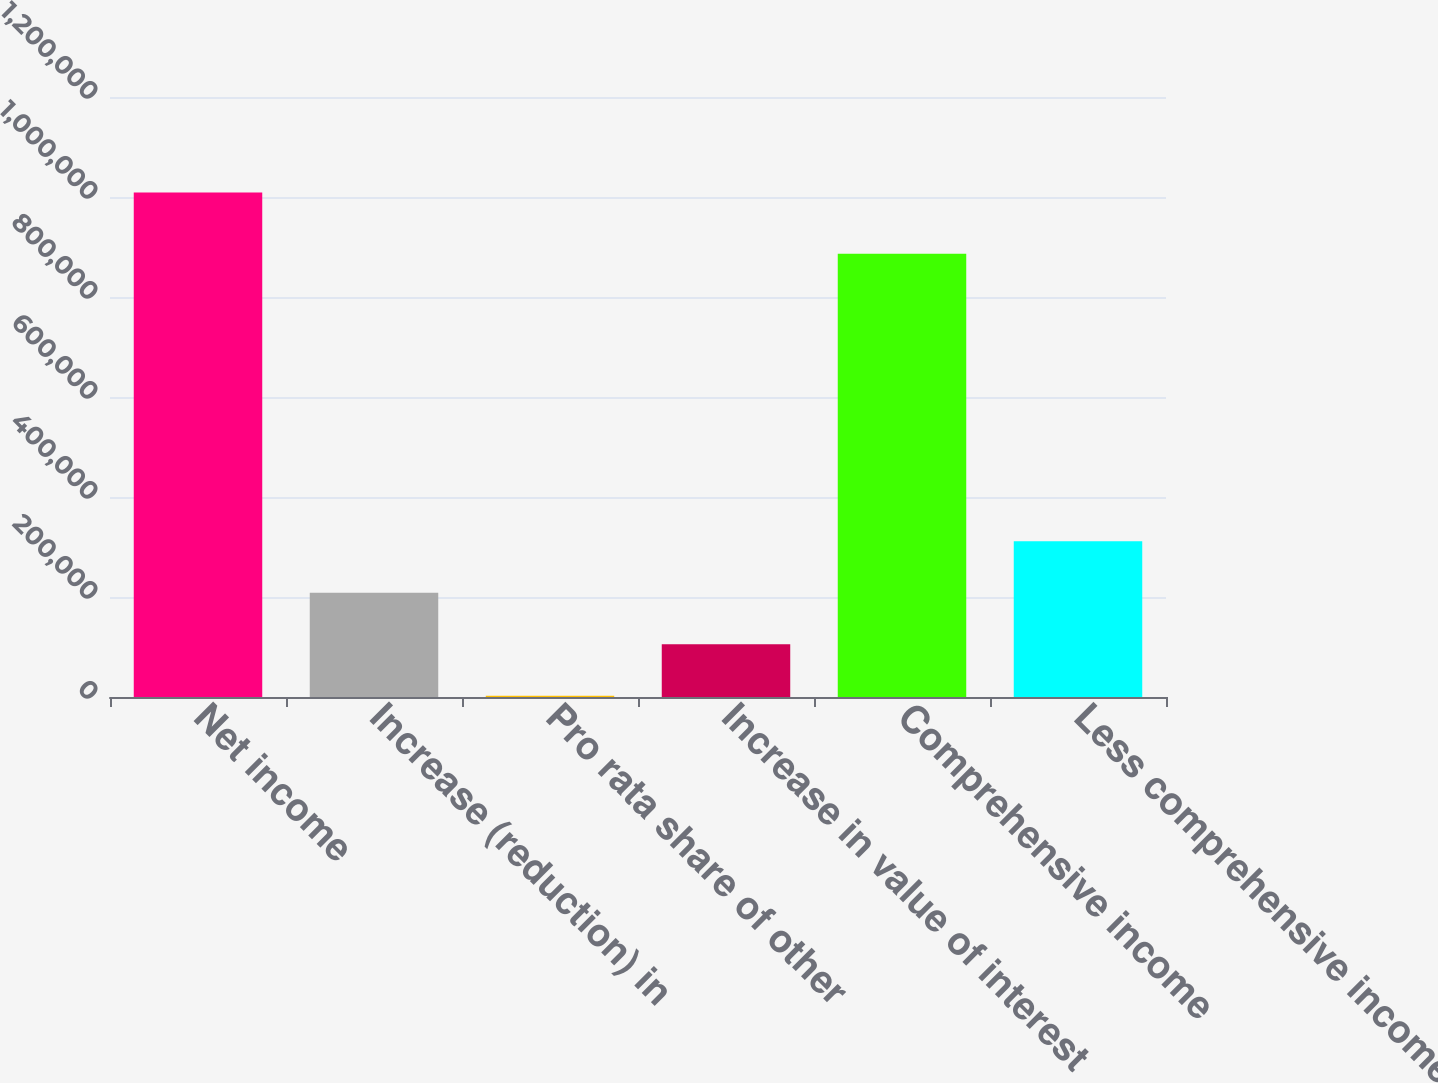Convert chart to OTSL. <chart><loc_0><loc_0><loc_500><loc_500><bar_chart><fcel>Net income<fcel>Increase (reduction) in<fcel>Pro rata share of other<fcel>Increase in value of interest<fcel>Comprehensive income<fcel>Less comprehensive income<nl><fcel>1.00903e+06<fcel>208423<fcel>2509<fcel>105466<fcel>886582<fcel>311380<nl></chart> 